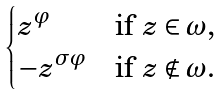Convert formula to latex. <formula><loc_0><loc_0><loc_500><loc_500>\begin{cases} z ^ { \varphi } & \text {if $z\in\omega$,} \\ - z ^ { \sigma \varphi } & \text {if $z\notin\omega$.} \end{cases}</formula> 